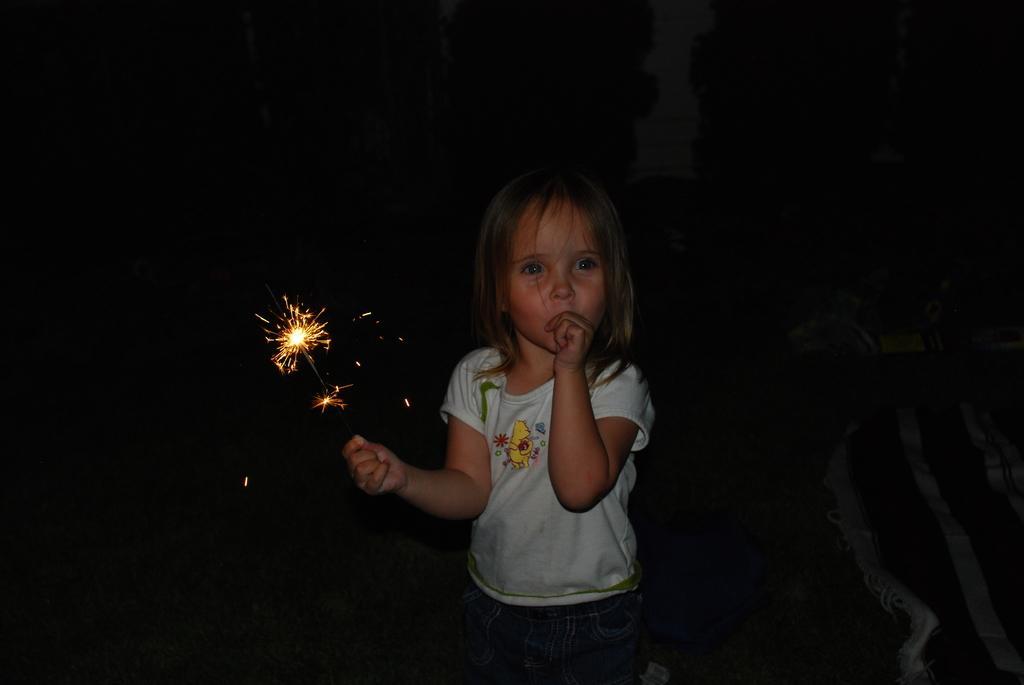Describe this image in one or two sentences. In this picture we can see a girl holding a firecracker with her hand and in the background it is dark. 